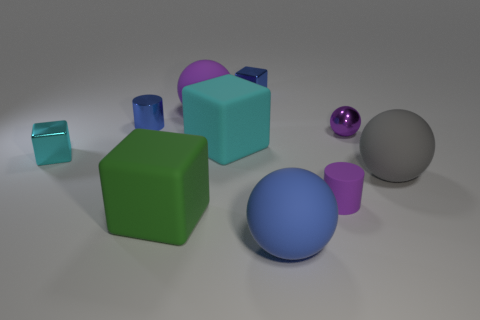Is there another gray object of the same shape as the gray object? Upon examining the image, it appears that there are multiple objects of distinct shapes and colors, including a gray sphere. However, there is not an additional gray object that shares the exact shape with the observed gray sphere. 